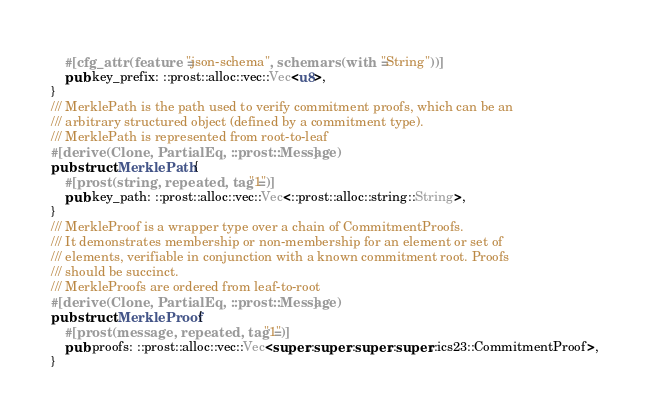<code> <loc_0><loc_0><loc_500><loc_500><_Rust_>    #[cfg_attr(feature = "json-schema", schemars(with = "String"))]
    pub key_prefix: ::prost::alloc::vec::Vec<u8>,
}
/// MerklePath is the path used to verify commitment proofs, which can be an
/// arbitrary structured object (defined by a commitment type).
/// MerklePath is represented from root-to-leaf
#[derive(Clone, PartialEq, ::prost::Message)]
pub struct MerklePath {
    #[prost(string, repeated, tag = "1")]
    pub key_path: ::prost::alloc::vec::Vec<::prost::alloc::string::String>,
}
/// MerkleProof is a wrapper type over a chain of CommitmentProofs.
/// It demonstrates membership or non-membership for an element or set of
/// elements, verifiable in conjunction with a known commitment root. Proofs
/// should be succinct.
/// MerkleProofs are ordered from leaf-to-root
#[derive(Clone, PartialEq, ::prost::Message)]
pub struct MerkleProof {
    #[prost(message, repeated, tag = "1")]
    pub proofs: ::prost::alloc::vec::Vec<super::super::super::super::ics23::CommitmentProof>,
}
</code> 